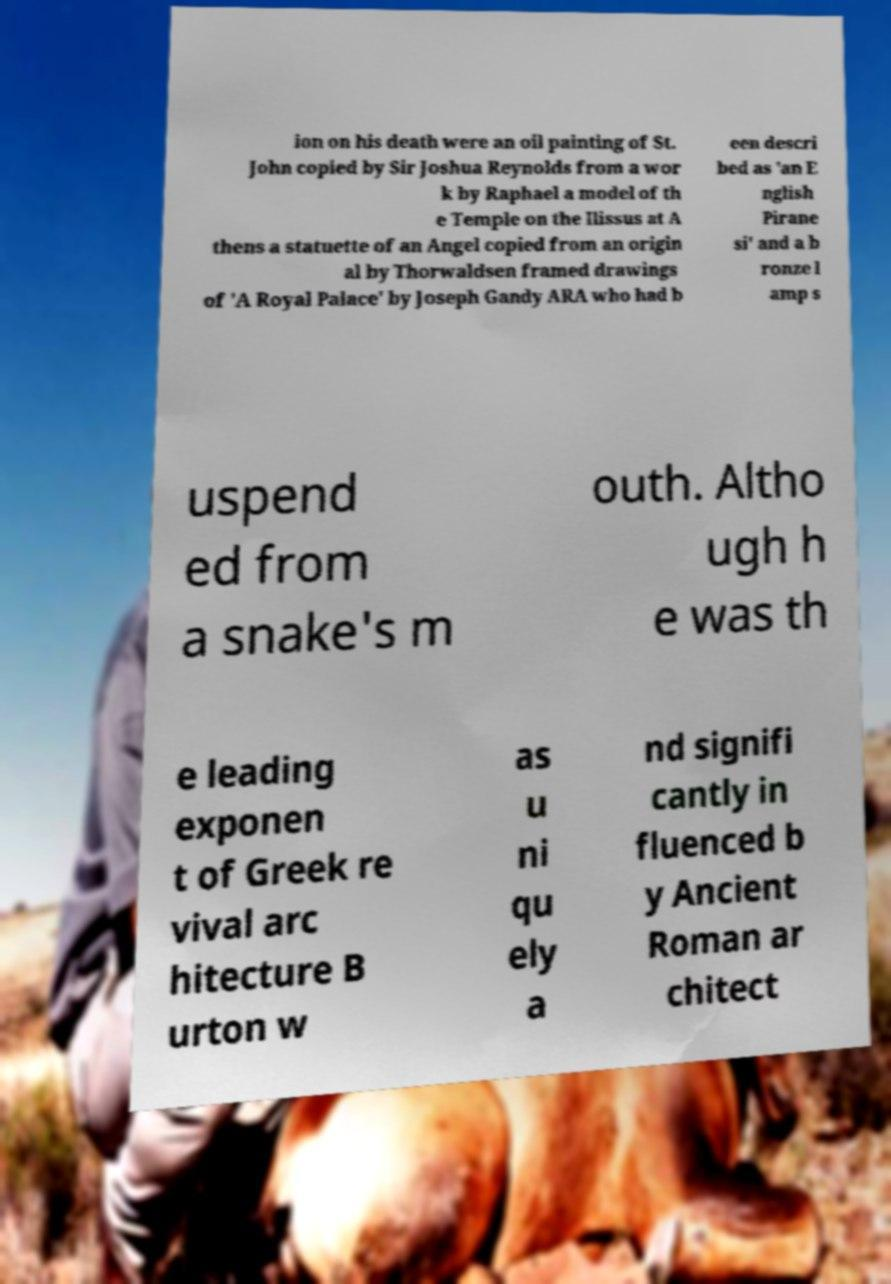Please read and relay the text visible in this image. What does it say? ion on his death were an oil painting of St. John copied by Sir Joshua Reynolds from a wor k by Raphael a model of th e Temple on the Ilissus at A thens a statuette of an Angel copied from an origin al by Thorwaldsen framed drawings of 'A Royal Palace' by Joseph Gandy ARA who had b een descri bed as 'an E nglish Pirane si' and a b ronze l amp s uspend ed from a snake's m outh. Altho ugh h e was th e leading exponen t of Greek re vival arc hitecture B urton w as u ni qu ely a nd signifi cantly in fluenced b y Ancient Roman ar chitect 